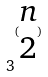Convert formula to latex. <formula><loc_0><loc_0><loc_500><loc_500>3 ^ { ( \begin{matrix} n \\ 2 \end{matrix} ) }</formula> 